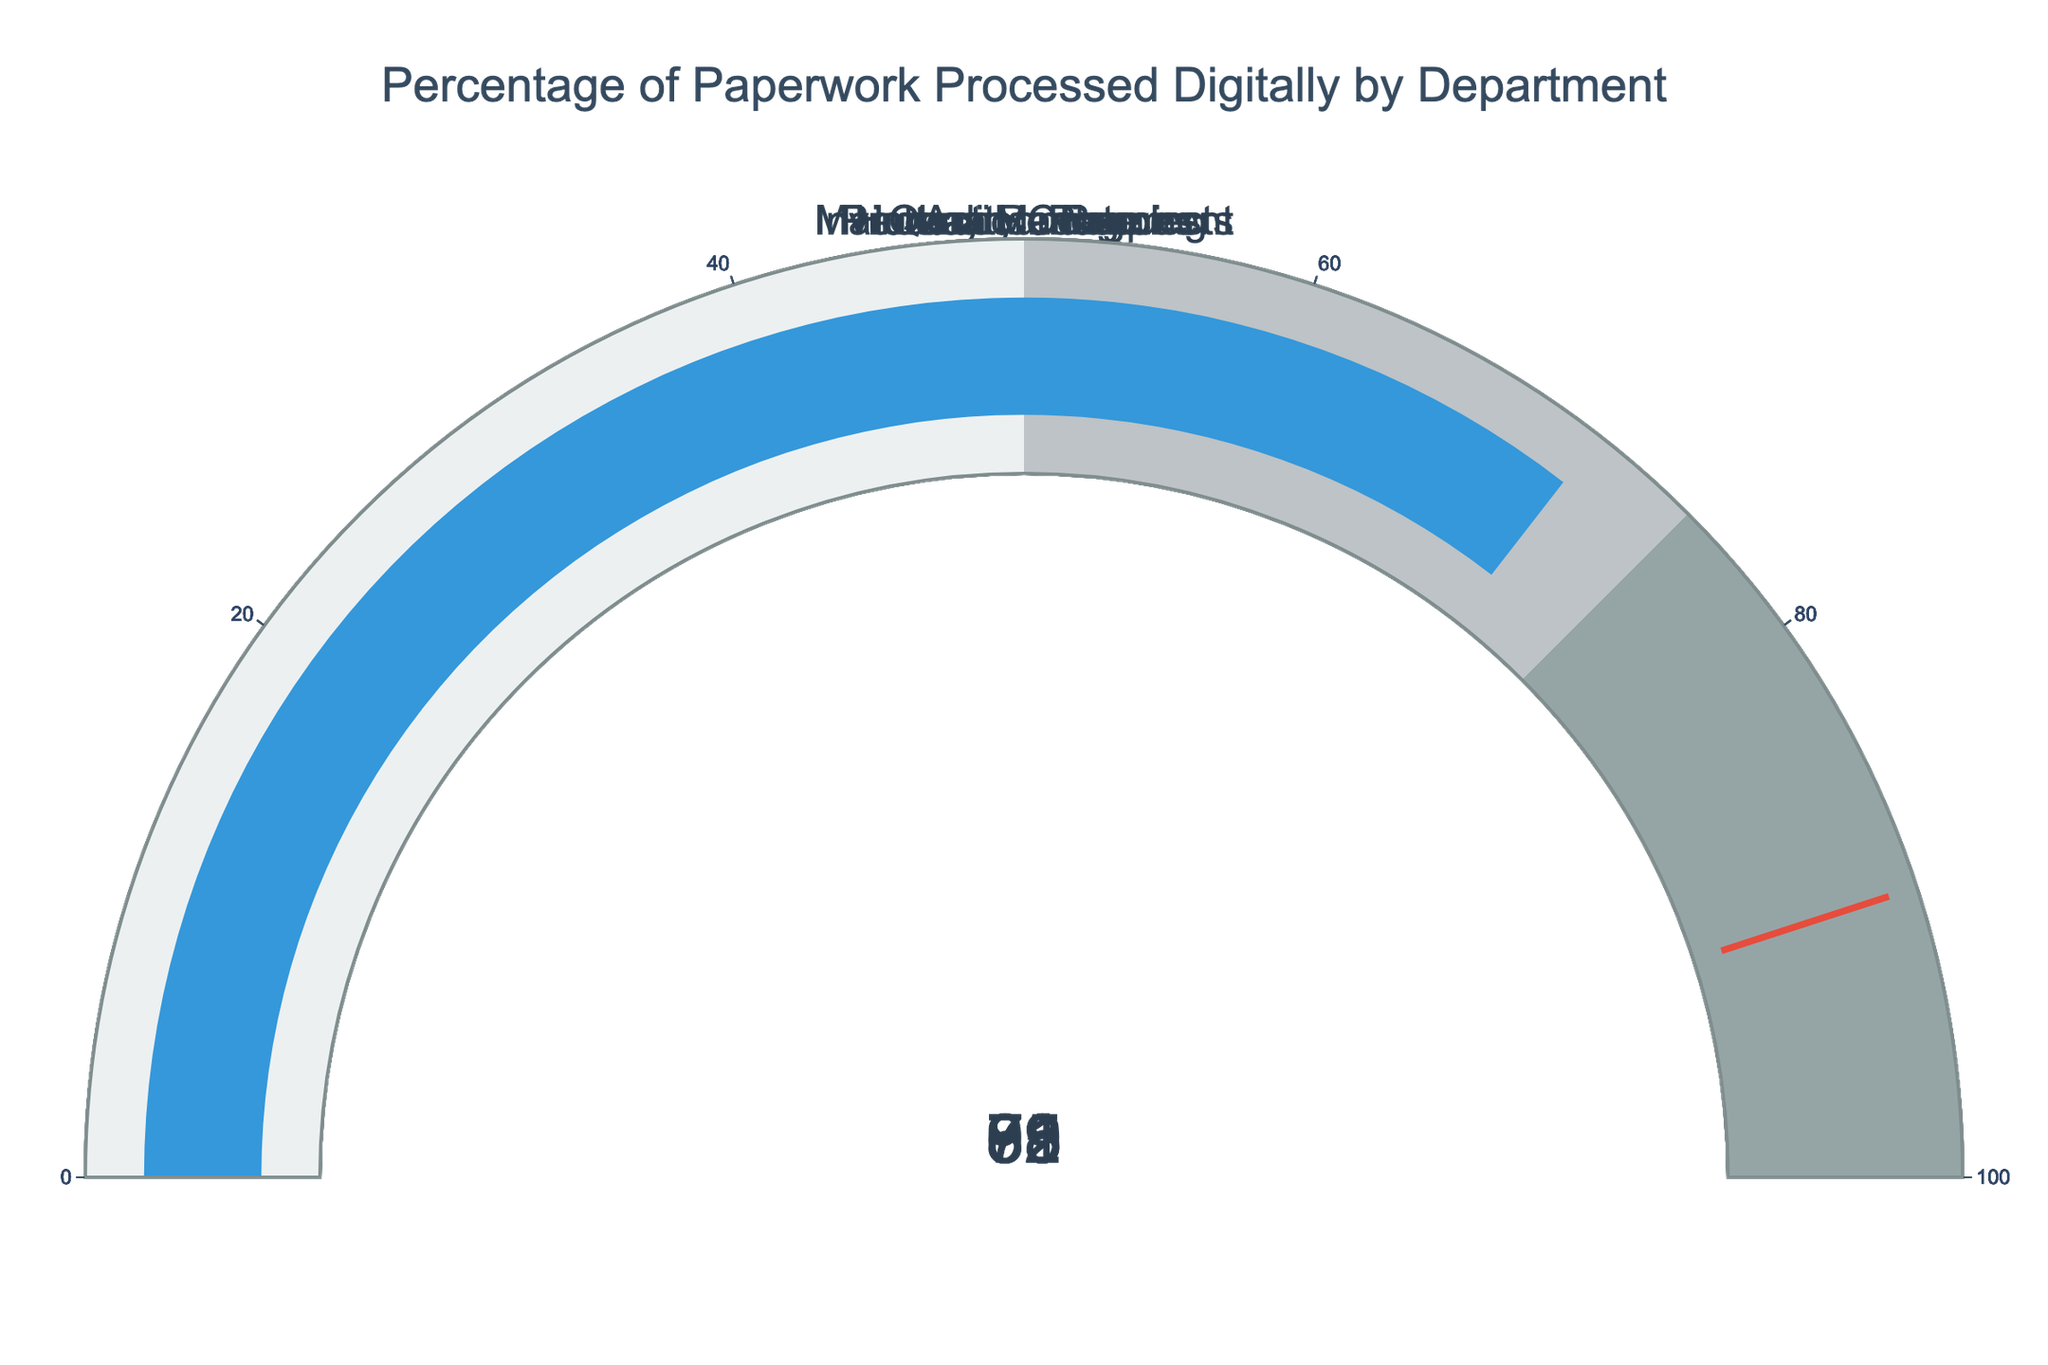what's the highest percentage of paperwork processed digitally? Check all the gauges to identify the one with the highest percentage. The gauge for the Accounting department shows the highest percentage at 92%
Answer: 92% which department has processed the least percentage of paperwork digitally? Compare the values on all the gauges. The Quality Control department has the lowest percentage at 63%
Answer: Quality Control what's the average percentage of paperwork processed digitally across all departments? Add all the percentages and divide by the number of departments: (78 + 92 + 85 + 63 + 89 + 71) / 6 = 478 / 6
Answer: 79.67 which departments have a digital processing percentage above 80%? Identify gauges with values above 80. These are Human Resources (78%), Production Planning (85%), Accounting (92%), and Inventory Management (89%)
Answer: Human Resources, Production Planning, Accounting, Inventory Management how many departments have a digital processing percentage below 75%? Count the number of gauges with values below 75. These are Quality Control (63%) and Maintenance Requests (71%).
Answer: 2 what percentage threshold marks the transition from average to good digital processing in this chart? Check the color-coded steps in the gauge. The threshold between the second and third segments (grey to light grey) is approximately 75%
Answer: 75% what's the total percentage of paperwork processed digitally across all departments? Sum all the percentages: 78 + 92 + 85 + 63 + 89 + 71 = 478
Answer: 478 if we only consider departments with a percentage above 70%, what's their average digital processing percentage? First identify departments: HR (78), Accounting (92), Production (85), Inventory (89), Maintenance (71). Then calculate the average: (78 + 92 + 85 + 89 + 71) / 5 = 415 / 5
Answer: 83 which department needs the most improvement to reach the threshold of 90%? Calculate the difference between each department's percentage and 90%. Quality Control's 63% is the farthest from 90 at a difference of 27
Answer: Quality Control 